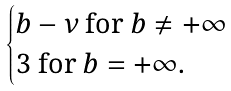Convert formula to latex. <formula><loc_0><loc_0><loc_500><loc_500>\begin{cases} b - \nu \text { for } b \not = + \infty \\ 3 \text { for } b = + \infty . \end{cases}</formula> 